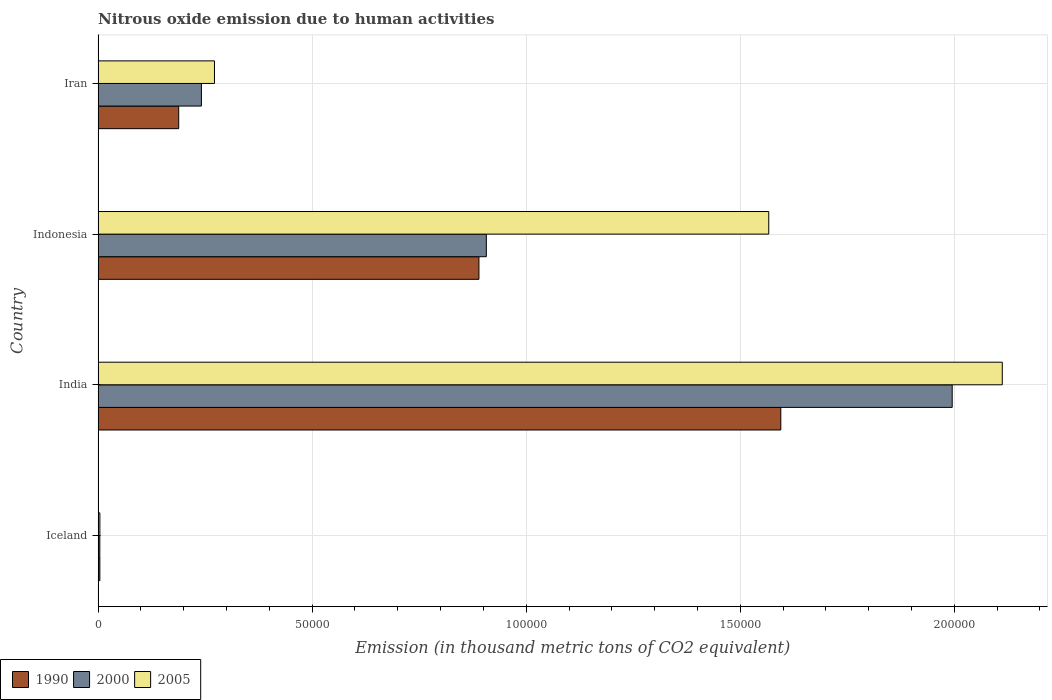How many different coloured bars are there?
Give a very brief answer. 3. How many bars are there on the 2nd tick from the bottom?
Your response must be concise. 3. In how many cases, is the number of bars for a given country not equal to the number of legend labels?
Give a very brief answer. 0. What is the amount of nitrous oxide emitted in 2005 in Iceland?
Keep it short and to the point. 410.9. Across all countries, what is the maximum amount of nitrous oxide emitted in 2005?
Your answer should be compact. 2.11e+05. Across all countries, what is the minimum amount of nitrous oxide emitted in 2000?
Keep it short and to the point. 395. In which country was the amount of nitrous oxide emitted in 1990 minimum?
Offer a very short reply. Iceland. What is the total amount of nitrous oxide emitted in 2005 in the graph?
Ensure brevity in your answer.  3.95e+05. What is the difference between the amount of nitrous oxide emitted in 2000 in Iceland and that in Indonesia?
Make the answer very short. -9.03e+04. What is the difference between the amount of nitrous oxide emitted in 1990 in India and the amount of nitrous oxide emitted in 2005 in Iceland?
Offer a terse response. 1.59e+05. What is the average amount of nitrous oxide emitted in 2005 per country?
Provide a short and direct response. 9.89e+04. What is the difference between the amount of nitrous oxide emitted in 2005 and amount of nitrous oxide emitted in 2000 in Indonesia?
Your answer should be very brief. 6.60e+04. In how many countries, is the amount of nitrous oxide emitted in 2000 greater than 210000 thousand metric tons?
Ensure brevity in your answer.  0. What is the ratio of the amount of nitrous oxide emitted in 2005 in Iceland to that in Indonesia?
Provide a succinct answer. 0. Is the difference between the amount of nitrous oxide emitted in 2005 in Iceland and Iran greater than the difference between the amount of nitrous oxide emitted in 2000 in Iceland and Iran?
Your answer should be compact. No. What is the difference between the highest and the second highest amount of nitrous oxide emitted in 1990?
Keep it short and to the point. 7.05e+04. What is the difference between the highest and the lowest amount of nitrous oxide emitted in 2005?
Keep it short and to the point. 2.11e+05. Is the sum of the amount of nitrous oxide emitted in 2000 in India and Indonesia greater than the maximum amount of nitrous oxide emitted in 1990 across all countries?
Ensure brevity in your answer.  Yes. What does the 2nd bar from the top in Iran represents?
Your answer should be very brief. 2000. How many bars are there?
Your response must be concise. 12. Are all the bars in the graph horizontal?
Make the answer very short. Yes. How many countries are there in the graph?
Your answer should be compact. 4. Are the values on the major ticks of X-axis written in scientific E-notation?
Ensure brevity in your answer.  No. How many legend labels are there?
Provide a short and direct response. 3. What is the title of the graph?
Your response must be concise. Nitrous oxide emission due to human activities. What is the label or title of the X-axis?
Provide a short and direct response. Emission (in thousand metric tons of CO2 equivalent). What is the label or title of the Y-axis?
Keep it short and to the point. Country. What is the Emission (in thousand metric tons of CO2 equivalent) in 1990 in Iceland?
Your response must be concise. 404. What is the Emission (in thousand metric tons of CO2 equivalent) of 2000 in Iceland?
Your answer should be compact. 395. What is the Emission (in thousand metric tons of CO2 equivalent) of 2005 in Iceland?
Your answer should be very brief. 410.9. What is the Emission (in thousand metric tons of CO2 equivalent) in 1990 in India?
Your answer should be compact. 1.59e+05. What is the Emission (in thousand metric tons of CO2 equivalent) in 2000 in India?
Make the answer very short. 1.99e+05. What is the Emission (in thousand metric tons of CO2 equivalent) in 2005 in India?
Offer a terse response. 2.11e+05. What is the Emission (in thousand metric tons of CO2 equivalent) in 1990 in Indonesia?
Offer a terse response. 8.89e+04. What is the Emission (in thousand metric tons of CO2 equivalent) in 2000 in Indonesia?
Your response must be concise. 9.07e+04. What is the Emission (in thousand metric tons of CO2 equivalent) in 2005 in Indonesia?
Give a very brief answer. 1.57e+05. What is the Emission (in thousand metric tons of CO2 equivalent) in 1990 in Iran?
Give a very brief answer. 1.88e+04. What is the Emission (in thousand metric tons of CO2 equivalent) in 2000 in Iran?
Your response must be concise. 2.41e+04. What is the Emission (in thousand metric tons of CO2 equivalent) in 2005 in Iran?
Ensure brevity in your answer.  2.72e+04. Across all countries, what is the maximum Emission (in thousand metric tons of CO2 equivalent) of 1990?
Give a very brief answer. 1.59e+05. Across all countries, what is the maximum Emission (in thousand metric tons of CO2 equivalent) in 2000?
Make the answer very short. 1.99e+05. Across all countries, what is the maximum Emission (in thousand metric tons of CO2 equivalent) in 2005?
Ensure brevity in your answer.  2.11e+05. Across all countries, what is the minimum Emission (in thousand metric tons of CO2 equivalent) in 1990?
Provide a succinct answer. 404. Across all countries, what is the minimum Emission (in thousand metric tons of CO2 equivalent) of 2000?
Make the answer very short. 395. Across all countries, what is the minimum Emission (in thousand metric tons of CO2 equivalent) of 2005?
Give a very brief answer. 410.9. What is the total Emission (in thousand metric tons of CO2 equivalent) of 1990 in the graph?
Your answer should be compact. 2.68e+05. What is the total Emission (in thousand metric tons of CO2 equivalent) of 2000 in the graph?
Ensure brevity in your answer.  3.15e+05. What is the total Emission (in thousand metric tons of CO2 equivalent) of 2005 in the graph?
Provide a succinct answer. 3.95e+05. What is the difference between the Emission (in thousand metric tons of CO2 equivalent) of 1990 in Iceland and that in India?
Your answer should be compact. -1.59e+05. What is the difference between the Emission (in thousand metric tons of CO2 equivalent) in 2000 in Iceland and that in India?
Keep it short and to the point. -1.99e+05. What is the difference between the Emission (in thousand metric tons of CO2 equivalent) of 2005 in Iceland and that in India?
Your response must be concise. -2.11e+05. What is the difference between the Emission (in thousand metric tons of CO2 equivalent) in 1990 in Iceland and that in Indonesia?
Give a very brief answer. -8.85e+04. What is the difference between the Emission (in thousand metric tons of CO2 equivalent) of 2000 in Iceland and that in Indonesia?
Your response must be concise. -9.03e+04. What is the difference between the Emission (in thousand metric tons of CO2 equivalent) of 2005 in Iceland and that in Indonesia?
Your answer should be compact. -1.56e+05. What is the difference between the Emission (in thousand metric tons of CO2 equivalent) of 1990 in Iceland and that in Iran?
Give a very brief answer. -1.84e+04. What is the difference between the Emission (in thousand metric tons of CO2 equivalent) of 2000 in Iceland and that in Iran?
Your response must be concise. -2.37e+04. What is the difference between the Emission (in thousand metric tons of CO2 equivalent) of 2005 in Iceland and that in Iran?
Provide a succinct answer. -2.68e+04. What is the difference between the Emission (in thousand metric tons of CO2 equivalent) in 1990 in India and that in Indonesia?
Give a very brief answer. 7.05e+04. What is the difference between the Emission (in thousand metric tons of CO2 equivalent) in 2000 in India and that in Indonesia?
Offer a very short reply. 1.09e+05. What is the difference between the Emission (in thousand metric tons of CO2 equivalent) of 2005 in India and that in Indonesia?
Keep it short and to the point. 5.45e+04. What is the difference between the Emission (in thousand metric tons of CO2 equivalent) in 1990 in India and that in Iran?
Offer a very short reply. 1.41e+05. What is the difference between the Emission (in thousand metric tons of CO2 equivalent) in 2000 in India and that in Iran?
Give a very brief answer. 1.75e+05. What is the difference between the Emission (in thousand metric tons of CO2 equivalent) in 2005 in India and that in Iran?
Offer a terse response. 1.84e+05. What is the difference between the Emission (in thousand metric tons of CO2 equivalent) of 1990 in Indonesia and that in Iran?
Provide a short and direct response. 7.01e+04. What is the difference between the Emission (in thousand metric tons of CO2 equivalent) in 2000 in Indonesia and that in Iran?
Your response must be concise. 6.65e+04. What is the difference between the Emission (in thousand metric tons of CO2 equivalent) in 2005 in Indonesia and that in Iran?
Ensure brevity in your answer.  1.29e+05. What is the difference between the Emission (in thousand metric tons of CO2 equivalent) in 1990 in Iceland and the Emission (in thousand metric tons of CO2 equivalent) in 2000 in India?
Give a very brief answer. -1.99e+05. What is the difference between the Emission (in thousand metric tons of CO2 equivalent) in 1990 in Iceland and the Emission (in thousand metric tons of CO2 equivalent) in 2005 in India?
Your answer should be very brief. -2.11e+05. What is the difference between the Emission (in thousand metric tons of CO2 equivalent) in 2000 in Iceland and the Emission (in thousand metric tons of CO2 equivalent) in 2005 in India?
Your answer should be compact. -2.11e+05. What is the difference between the Emission (in thousand metric tons of CO2 equivalent) in 1990 in Iceland and the Emission (in thousand metric tons of CO2 equivalent) in 2000 in Indonesia?
Your answer should be very brief. -9.03e+04. What is the difference between the Emission (in thousand metric tons of CO2 equivalent) in 1990 in Iceland and the Emission (in thousand metric tons of CO2 equivalent) in 2005 in Indonesia?
Ensure brevity in your answer.  -1.56e+05. What is the difference between the Emission (in thousand metric tons of CO2 equivalent) in 2000 in Iceland and the Emission (in thousand metric tons of CO2 equivalent) in 2005 in Indonesia?
Keep it short and to the point. -1.56e+05. What is the difference between the Emission (in thousand metric tons of CO2 equivalent) in 1990 in Iceland and the Emission (in thousand metric tons of CO2 equivalent) in 2000 in Iran?
Offer a very short reply. -2.37e+04. What is the difference between the Emission (in thousand metric tons of CO2 equivalent) of 1990 in Iceland and the Emission (in thousand metric tons of CO2 equivalent) of 2005 in Iran?
Give a very brief answer. -2.68e+04. What is the difference between the Emission (in thousand metric tons of CO2 equivalent) of 2000 in Iceland and the Emission (in thousand metric tons of CO2 equivalent) of 2005 in Iran?
Keep it short and to the point. -2.68e+04. What is the difference between the Emission (in thousand metric tons of CO2 equivalent) in 1990 in India and the Emission (in thousand metric tons of CO2 equivalent) in 2000 in Indonesia?
Ensure brevity in your answer.  6.88e+04. What is the difference between the Emission (in thousand metric tons of CO2 equivalent) of 1990 in India and the Emission (in thousand metric tons of CO2 equivalent) of 2005 in Indonesia?
Your answer should be compact. 2817.9. What is the difference between the Emission (in thousand metric tons of CO2 equivalent) in 2000 in India and the Emission (in thousand metric tons of CO2 equivalent) in 2005 in Indonesia?
Make the answer very short. 4.29e+04. What is the difference between the Emission (in thousand metric tons of CO2 equivalent) of 1990 in India and the Emission (in thousand metric tons of CO2 equivalent) of 2000 in Iran?
Your response must be concise. 1.35e+05. What is the difference between the Emission (in thousand metric tons of CO2 equivalent) of 1990 in India and the Emission (in thousand metric tons of CO2 equivalent) of 2005 in Iran?
Keep it short and to the point. 1.32e+05. What is the difference between the Emission (in thousand metric tons of CO2 equivalent) of 2000 in India and the Emission (in thousand metric tons of CO2 equivalent) of 2005 in Iran?
Give a very brief answer. 1.72e+05. What is the difference between the Emission (in thousand metric tons of CO2 equivalent) in 1990 in Indonesia and the Emission (in thousand metric tons of CO2 equivalent) in 2000 in Iran?
Ensure brevity in your answer.  6.48e+04. What is the difference between the Emission (in thousand metric tons of CO2 equivalent) of 1990 in Indonesia and the Emission (in thousand metric tons of CO2 equivalent) of 2005 in Iran?
Your response must be concise. 6.18e+04. What is the difference between the Emission (in thousand metric tons of CO2 equivalent) in 2000 in Indonesia and the Emission (in thousand metric tons of CO2 equivalent) in 2005 in Iran?
Provide a succinct answer. 6.35e+04. What is the average Emission (in thousand metric tons of CO2 equivalent) of 1990 per country?
Offer a very short reply. 6.69e+04. What is the average Emission (in thousand metric tons of CO2 equivalent) in 2000 per country?
Ensure brevity in your answer.  7.87e+04. What is the average Emission (in thousand metric tons of CO2 equivalent) of 2005 per country?
Give a very brief answer. 9.89e+04. What is the difference between the Emission (in thousand metric tons of CO2 equivalent) in 2000 and Emission (in thousand metric tons of CO2 equivalent) in 2005 in Iceland?
Your response must be concise. -15.9. What is the difference between the Emission (in thousand metric tons of CO2 equivalent) of 1990 and Emission (in thousand metric tons of CO2 equivalent) of 2000 in India?
Provide a succinct answer. -4.00e+04. What is the difference between the Emission (in thousand metric tons of CO2 equivalent) in 1990 and Emission (in thousand metric tons of CO2 equivalent) in 2005 in India?
Offer a very short reply. -5.17e+04. What is the difference between the Emission (in thousand metric tons of CO2 equivalent) in 2000 and Emission (in thousand metric tons of CO2 equivalent) in 2005 in India?
Your answer should be very brief. -1.17e+04. What is the difference between the Emission (in thousand metric tons of CO2 equivalent) of 1990 and Emission (in thousand metric tons of CO2 equivalent) of 2000 in Indonesia?
Offer a very short reply. -1727.1. What is the difference between the Emission (in thousand metric tons of CO2 equivalent) in 1990 and Emission (in thousand metric tons of CO2 equivalent) in 2005 in Indonesia?
Provide a succinct answer. -6.77e+04. What is the difference between the Emission (in thousand metric tons of CO2 equivalent) of 2000 and Emission (in thousand metric tons of CO2 equivalent) of 2005 in Indonesia?
Your response must be concise. -6.60e+04. What is the difference between the Emission (in thousand metric tons of CO2 equivalent) in 1990 and Emission (in thousand metric tons of CO2 equivalent) in 2000 in Iran?
Your answer should be compact. -5303. What is the difference between the Emission (in thousand metric tons of CO2 equivalent) in 1990 and Emission (in thousand metric tons of CO2 equivalent) in 2005 in Iran?
Offer a terse response. -8355.6. What is the difference between the Emission (in thousand metric tons of CO2 equivalent) of 2000 and Emission (in thousand metric tons of CO2 equivalent) of 2005 in Iran?
Offer a terse response. -3052.6. What is the ratio of the Emission (in thousand metric tons of CO2 equivalent) in 1990 in Iceland to that in India?
Your response must be concise. 0. What is the ratio of the Emission (in thousand metric tons of CO2 equivalent) of 2000 in Iceland to that in India?
Keep it short and to the point. 0. What is the ratio of the Emission (in thousand metric tons of CO2 equivalent) in 2005 in Iceland to that in India?
Give a very brief answer. 0. What is the ratio of the Emission (in thousand metric tons of CO2 equivalent) of 1990 in Iceland to that in Indonesia?
Ensure brevity in your answer.  0. What is the ratio of the Emission (in thousand metric tons of CO2 equivalent) of 2000 in Iceland to that in Indonesia?
Keep it short and to the point. 0. What is the ratio of the Emission (in thousand metric tons of CO2 equivalent) in 2005 in Iceland to that in Indonesia?
Your answer should be very brief. 0. What is the ratio of the Emission (in thousand metric tons of CO2 equivalent) in 1990 in Iceland to that in Iran?
Provide a short and direct response. 0.02. What is the ratio of the Emission (in thousand metric tons of CO2 equivalent) of 2000 in Iceland to that in Iran?
Offer a terse response. 0.02. What is the ratio of the Emission (in thousand metric tons of CO2 equivalent) of 2005 in Iceland to that in Iran?
Your response must be concise. 0.02. What is the ratio of the Emission (in thousand metric tons of CO2 equivalent) of 1990 in India to that in Indonesia?
Give a very brief answer. 1.79. What is the ratio of the Emission (in thousand metric tons of CO2 equivalent) in 2000 in India to that in Indonesia?
Offer a very short reply. 2.2. What is the ratio of the Emission (in thousand metric tons of CO2 equivalent) of 2005 in India to that in Indonesia?
Make the answer very short. 1.35. What is the ratio of the Emission (in thousand metric tons of CO2 equivalent) in 1990 in India to that in Iran?
Offer a terse response. 8.47. What is the ratio of the Emission (in thousand metric tons of CO2 equivalent) of 2000 in India to that in Iran?
Keep it short and to the point. 8.27. What is the ratio of the Emission (in thousand metric tons of CO2 equivalent) in 2005 in India to that in Iran?
Keep it short and to the point. 7.77. What is the ratio of the Emission (in thousand metric tons of CO2 equivalent) in 1990 in Indonesia to that in Iran?
Make the answer very short. 4.73. What is the ratio of the Emission (in thousand metric tons of CO2 equivalent) of 2000 in Indonesia to that in Iran?
Provide a succinct answer. 3.76. What is the ratio of the Emission (in thousand metric tons of CO2 equivalent) of 2005 in Indonesia to that in Iran?
Your answer should be compact. 5.76. What is the difference between the highest and the second highest Emission (in thousand metric tons of CO2 equivalent) in 1990?
Offer a very short reply. 7.05e+04. What is the difference between the highest and the second highest Emission (in thousand metric tons of CO2 equivalent) of 2000?
Offer a terse response. 1.09e+05. What is the difference between the highest and the second highest Emission (in thousand metric tons of CO2 equivalent) of 2005?
Your answer should be compact. 5.45e+04. What is the difference between the highest and the lowest Emission (in thousand metric tons of CO2 equivalent) in 1990?
Your answer should be compact. 1.59e+05. What is the difference between the highest and the lowest Emission (in thousand metric tons of CO2 equivalent) in 2000?
Provide a short and direct response. 1.99e+05. What is the difference between the highest and the lowest Emission (in thousand metric tons of CO2 equivalent) of 2005?
Keep it short and to the point. 2.11e+05. 